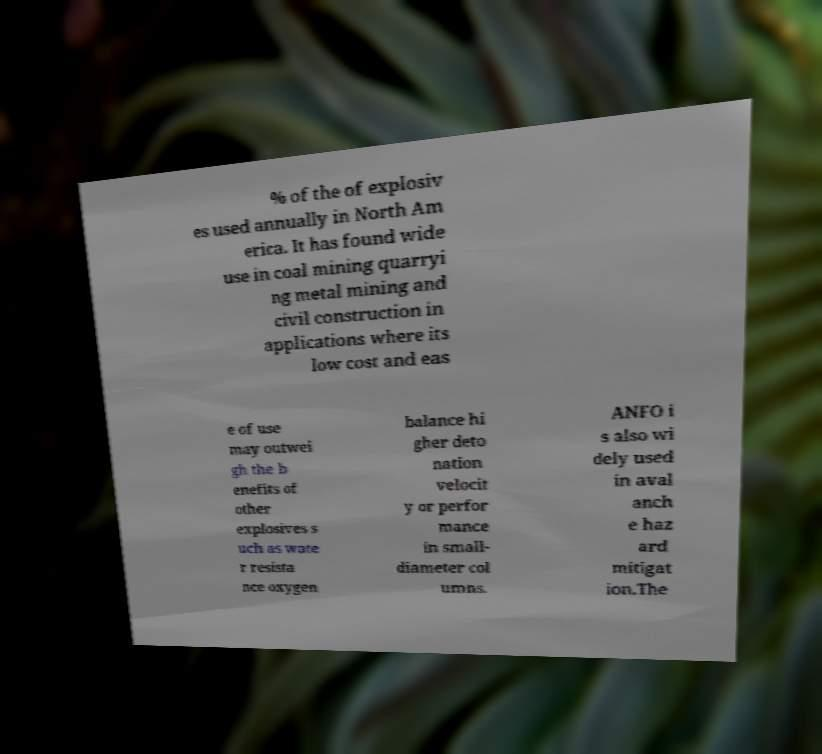For documentation purposes, I need the text within this image transcribed. Could you provide that? % of the of explosiv es used annually in North Am erica. It has found wide use in coal mining quarryi ng metal mining and civil construction in applications where its low cost and eas e of use may outwei gh the b enefits of other explosives s uch as wate r resista nce oxygen balance hi gher deto nation velocit y or perfor mance in small- diameter col umns. ANFO i s also wi dely used in aval anch e haz ard mitigat ion.The 